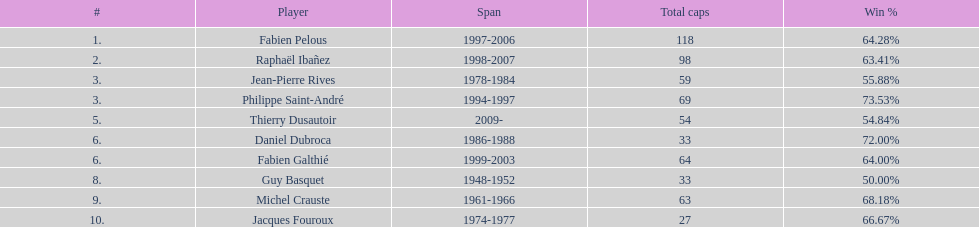How many caps did guy basquet accrue during his career? 33. Write the full table. {'header': ['#', 'Player', 'Span', 'Total caps', 'Win\xa0%'], 'rows': [['1.', 'Fabien Pelous', '1997-2006', '118', '64.28%'], ['2.', 'Raphaël Ibañez', '1998-2007', '98', '63.41%'], ['3.', 'Jean-Pierre Rives', '1978-1984', '59', '55.88%'], ['3.', 'Philippe Saint-André', '1994-1997', '69', '73.53%'], ['5.', 'Thierry Dusautoir', '2009-', '54', '54.84%'], ['6.', 'Daniel Dubroca', '1986-1988', '33', '72.00%'], ['6.', 'Fabien Galthié', '1999-2003', '64', '64.00%'], ['8.', 'Guy Basquet', '1948-1952', '33', '50.00%'], ['9.', 'Michel Crauste', '1961-1966', '63', '68.18%'], ['10.', 'Jacques Fouroux', '1974-1977', '27', '66.67%']]} 